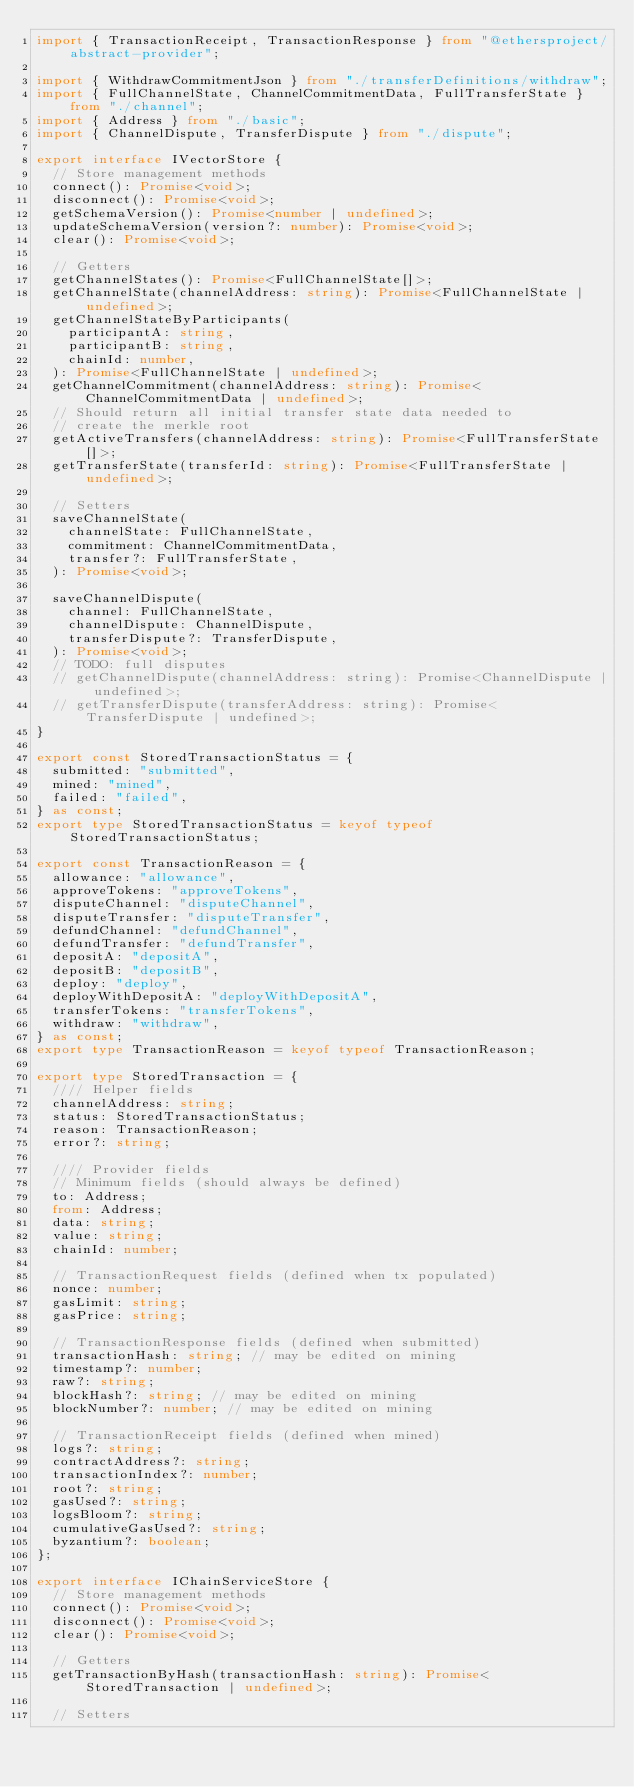<code> <loc_0><loc_0><loc_500><loc_500><_TypeScript_>import { TransactionReceipt, TransactionResponse } from "@ethersproject/abstract-provider";

import { WithdrawCommitmentJson } from "./transferDefinitions/withdraw";
import { FullChannelState, ChannelCommitmentData, FullTransferState } from "./channel";
import { Address } from "./basic";
import { ChannelDispute, TransferDispute } from "./dispute";

export interface IVectorStore {
  // Store management methods
  connect(): Promise<void>;
  disconnect(): Promise<void>;
  getSchemaVersion(): Promise<number | undefined>;
  updateSchemaVersion(version?: number): Promise<void>;
  clear(): Promise<void>;

  // Getters
  getChannelStates(): Promise<FullChannelState[]>;
  getChannelState(channelAddress: string): Promise<FullChannelState | undefined>;
  getChannelStateByParticipants(
    participantA: string,
    participantB: string,
    chainId: number,
  ): Promise<FullChannelState | undefined>;
  getChannelCommitment(channelAddress: string): Promise<ChannelCommitmentData | undefined>;
  // Should return all initial transfer state data needed to
  // create the merkle root
  getActiveTransfers(channelAddress: string): Promise<FullTransferState[]>;
  getTransferState(transferId: string): Promise<FullTransferState | undefined>;

  // Setters
  saveChannelState(
    channelState: FullChannelState,
    commitment: ChannelCommitmentData,
    transfer?: FullTransferState,
  ): Promise<void>;

  saveChannelDispute(
    channel: FullChannelState,
    channelDispute: ChannelDispute,
    transferDispute?: TransferDispute,
  ): Promise<void>;
  // TODO: full disputes
  // getChannelDispute(channelAddress: string): Promise<ChannelDispute | undefined>;
  // getTransferDispute(transferAddress: string): Promise<TransferDispute | undefined>;
}

export const StoredTransactionStatus = {
  submitted: "submitted",
  mined: "mined",
  failed: "failed",
} as const;
export type StoredTransactionStatus = keyof typeof StoredTransactionStatus;

export const TransactionReason = {
  allowance: "allowance",
  approveTokens: "approveTokens",
  disputeChannel: "disputeChannel",
  disputeTransfer: "disputeTransfer",
  defundChannel: "defundChannel",
  defundTransfer: "defundTransfer",
  depositA: "depositA",
  depositB: "depositB",
  deploy: "deploy",
  deployWithDepositA: "deployWithDepositA",
  transferTokens: "transferTokens",
  withdraw: "withdraw",
} as const;
export type TransactionReason = keyof typeof TransactionReason;

export type StoredTransaction = {
  //// Helper fields
  channelAddress: string;
  status: StoredTransactionStatus;
  reason: TransactionReason;
  error?: string;

  //// Provider fields
  // Minimum fields (should always be defined)
  to: Address;
  from: Address;
  data: string;
  value: string;
  chainId: number;

  // TransactionRequest fields (defined when tx populated)
  nonce: number;
  gasLimit: string;
  gasPrice: string;

  // TransactionResponse fields (defined when submitted)
  transactionHash: string; // may be edited on mining
  timestamp?: number;
  raw?: string;
  blockHash?: string; // may be edited on mining
  blockNumber?: number; // may be edited on mining

  // TransactionReceipt fields (defined when mined)
  logs?: string;
  contractAddress?: string;
  transactionIndex?: number;
  root?: string;
  gasUsed?: string;
  logsBloom?: string;
  cumulativeGasUsed?: string;
  byzantium?: boolean;
};

export interface IChainServiceStore {
  // Store management methods
  connect(): Promise<void>;
  disconnect(): Promise<void>;
  clear(): Promise<void>;

  // Getters
  getTransactionByHash(transactionHash: string): Promise<StoredTransaction | undefined>;

  // Setters</code> 